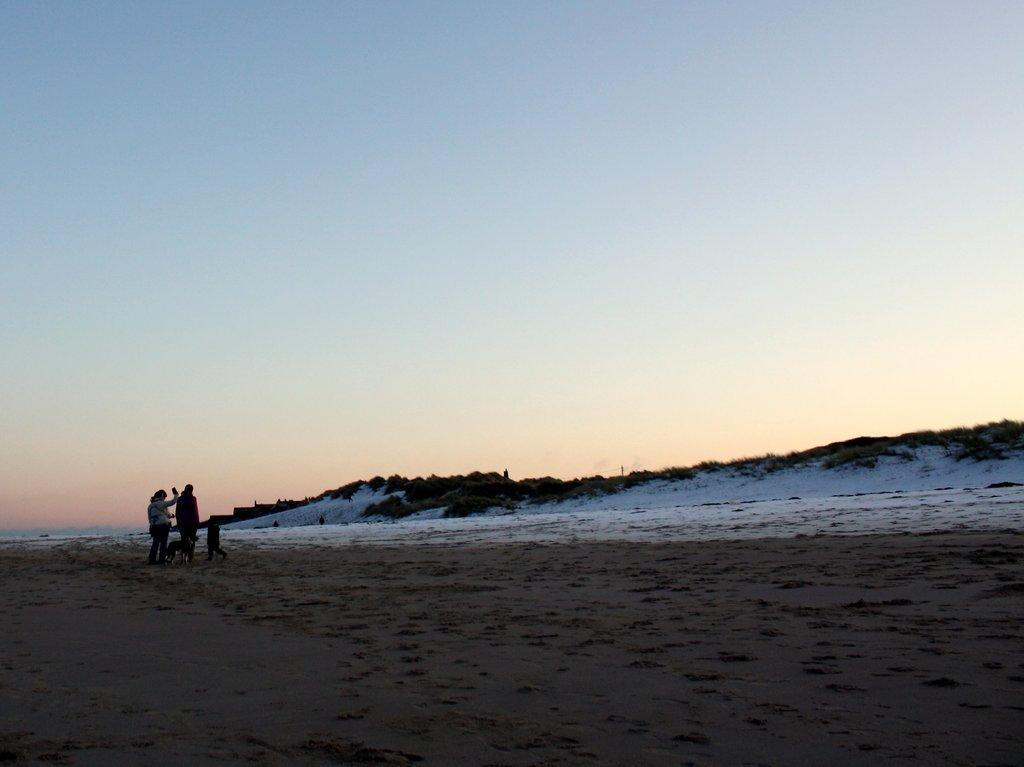In one or two sentences, can you explain what this image depicts? In the foreground of the picture there is sand. In the center towards left there are people standing. In the center of the picture there are shrubs and sand. Sky is clear. The picture is taken during evening. 